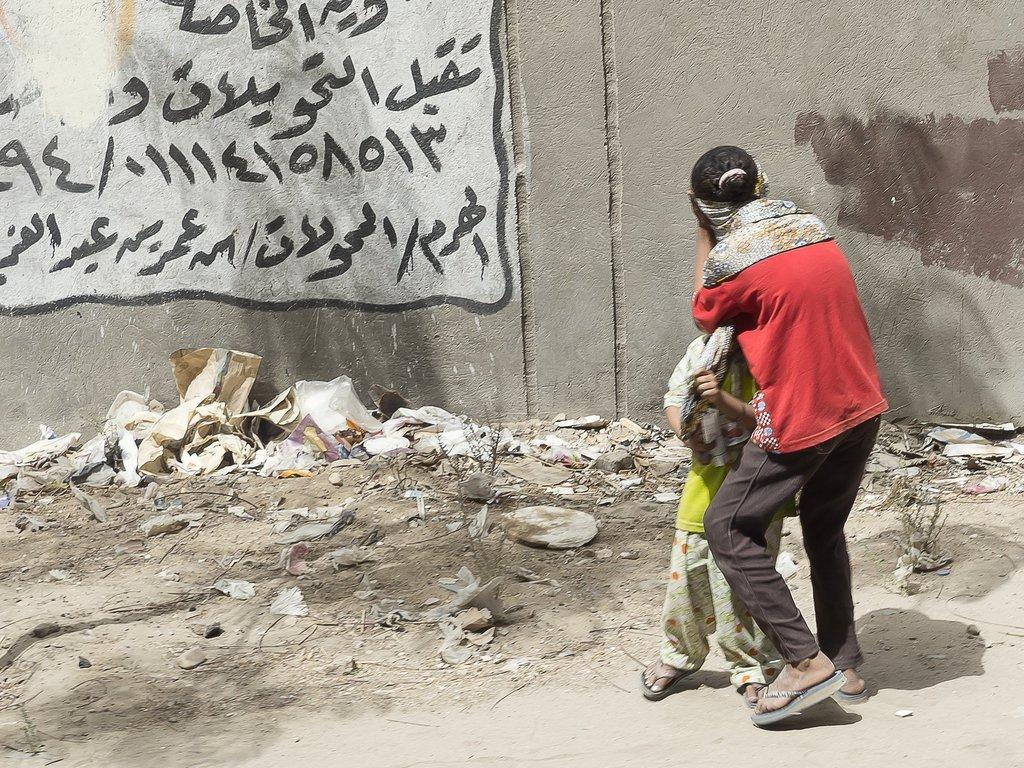What can be seen in the image involving human presence? There are people standing in the image. What type of surface is visible beneath the people? The ground is visible in the image. What is present on the ground in the image? There are objects on the ground. What architectural feature can be seen in the image? There is a wall in the image. What is written or displayed on the wall? Text is written on the wall. How many children are playing with leather balls in the image? There is no mention of children or leather balls in the image, so this information cannot be provided. 